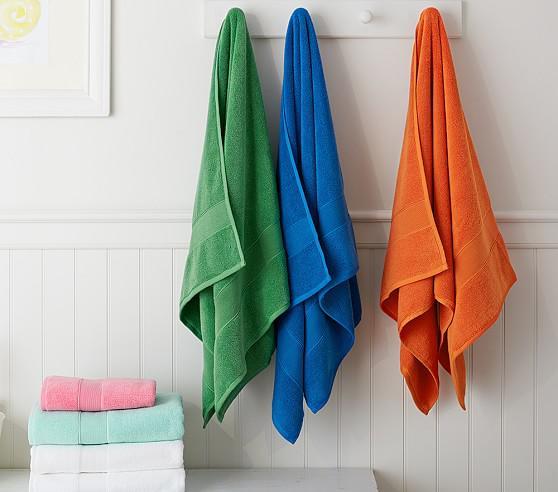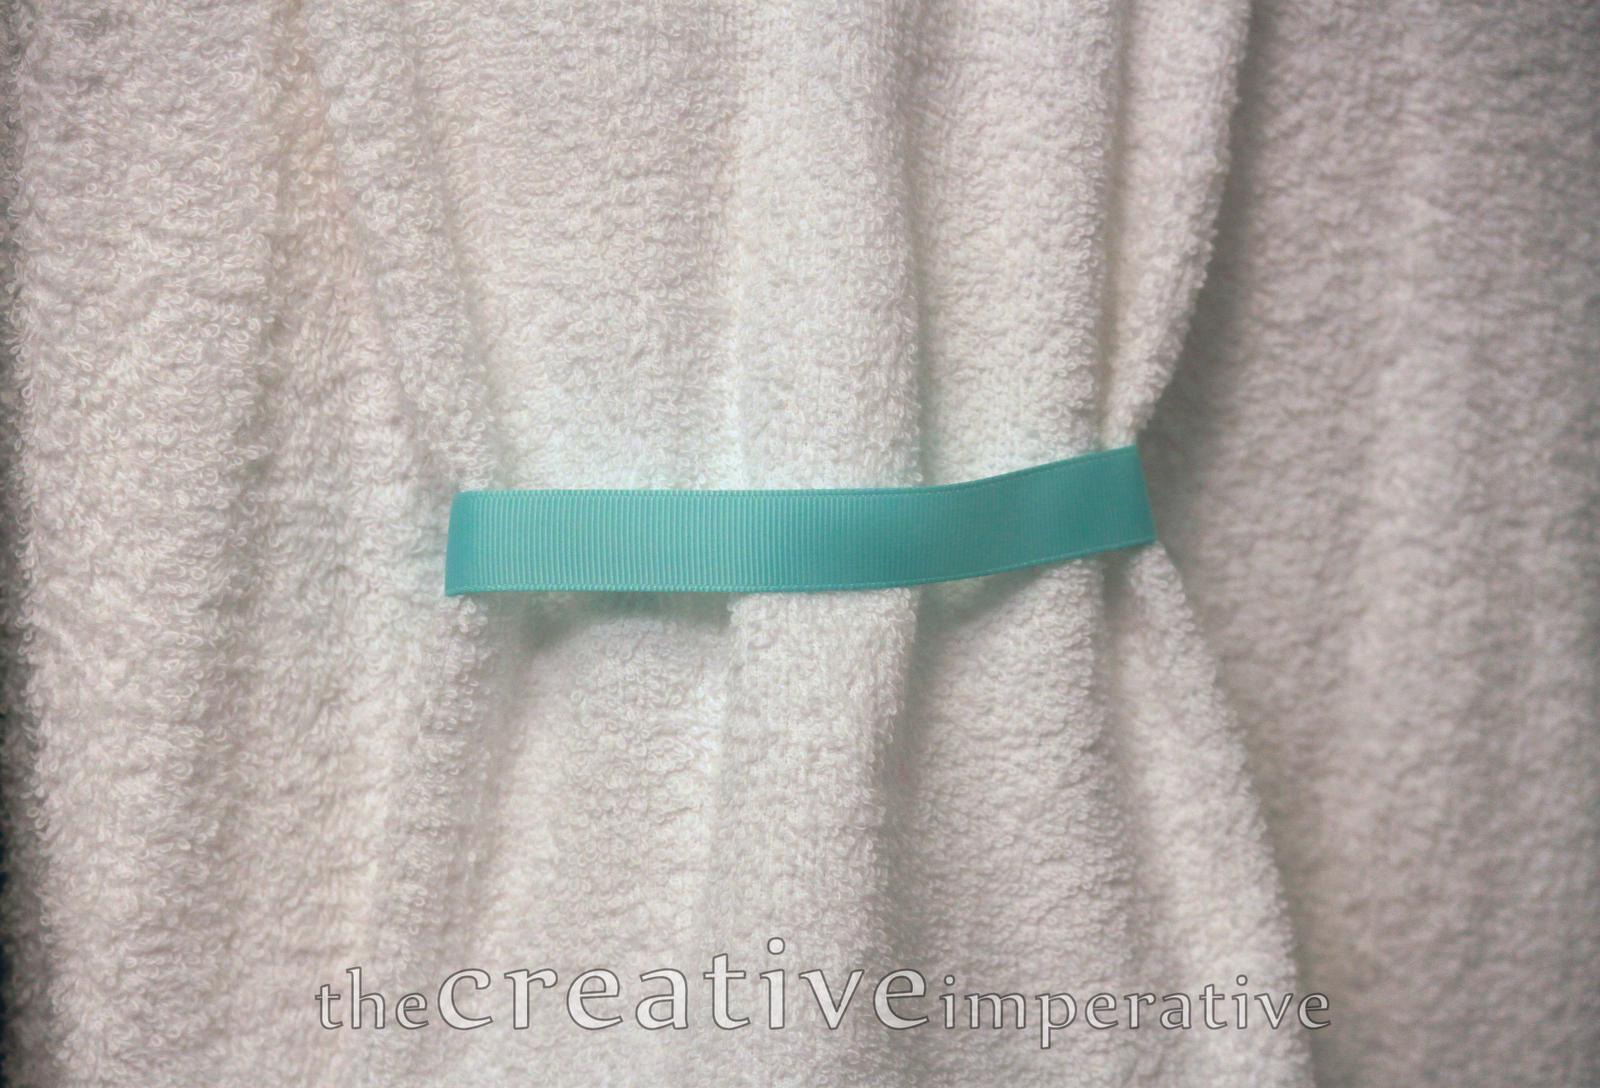The first image is the image on the left, the second image is the image on the right. Examine the images to the left and right. Is the description "One image shows flat, folded, overlapping cloths, and the other image shows the folded edges of white towels, each with differnt colored stripes." accurate? Answer yes or no. No. The first image is the image on the left, the second image is the image on the right. Evaluate the accuracy of this statement regarding the images: "In at least one image there are three hanging pieces of fabric in the bathroom.". Is it true? Answer yes or no. Yes. 